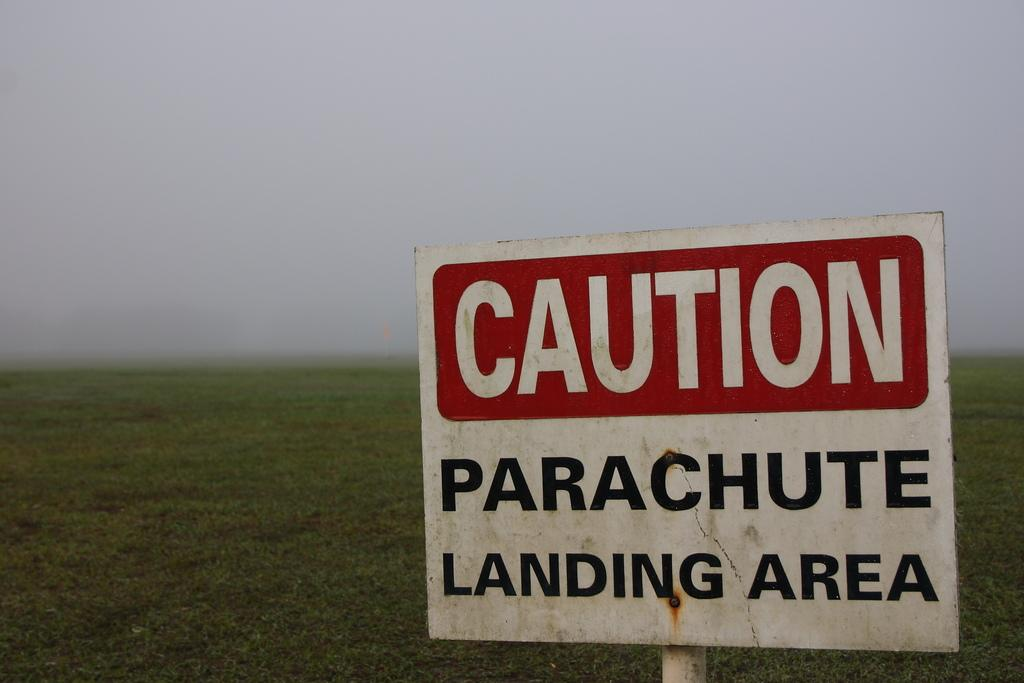Provide a one-sentence caption for the provided image. A sign sitting in the field with the words CAUTION Parachute landing area written on it. 